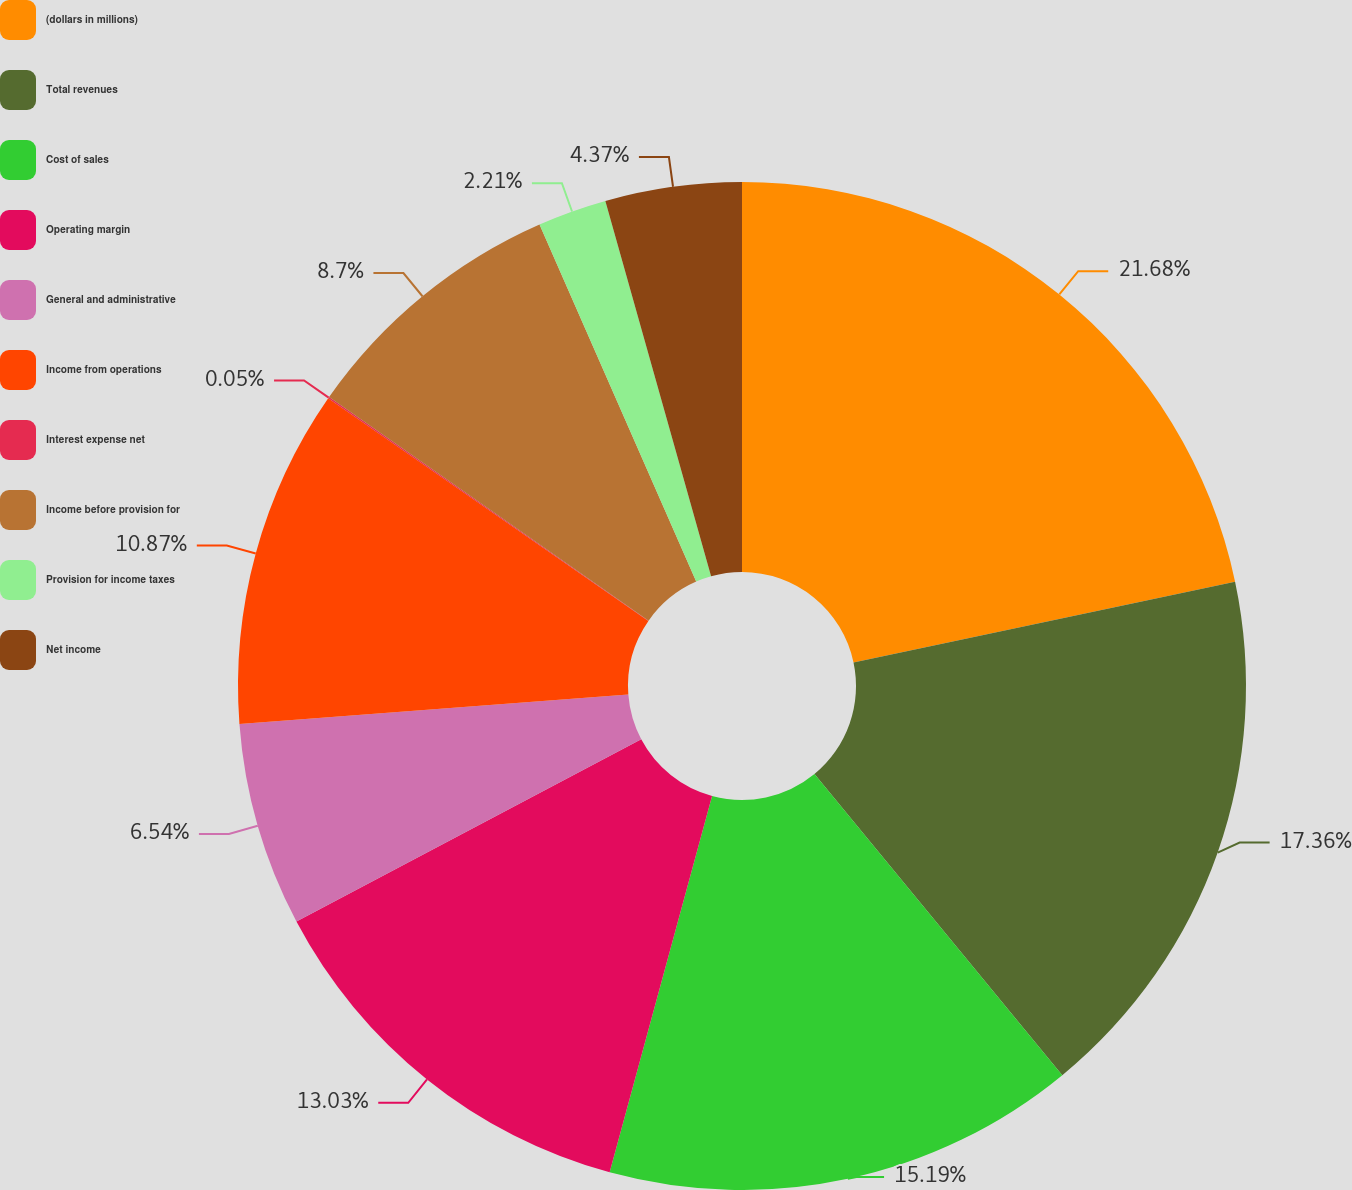Convert chart. <chart><loc_0><loc_0><loc_500><loc_500><pie_chart><fcel>(dollars in millions)<fcel>Total revenues<fcel>Cost of sales<fcel>Operating margin<fcel>General and administrative<fcel>Income from operations<fcel>Interest expense net<fcel>Income before provision for<fcel>Provision for income taxes<fcel>Net income<nl><fcel>21.68%<fcel>17.36%<fcel>15.19%<fcel>13.03%<fcel>6.54%<fcel>10.87%<fcel>0.05%<fcel>8.7%<fcel>2.21%<fcel>4.37%<nl></chart> 